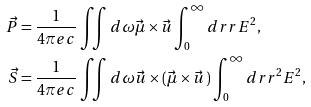Convert formula to latex. <formula><loc_0><loc_0><loc_500><loc_500>\vec { P } & = \frac { 1 } { 4 \pi e c } \iint d \omega \vec { \mu } \times \vec { u } \int _ { 0 } ^ { \infty } d r r E ^ { 2 } , \\ \vec { S } & = \frac { 1 } { 4 \pi e c } \iint d \omega \vec { u } \times ( \vec { \mu } \times \vec { u } \, ) \int _ { 0 } ^ { \infty } d r r ^ { 2 } E ^ { 2 } ,</formula> 